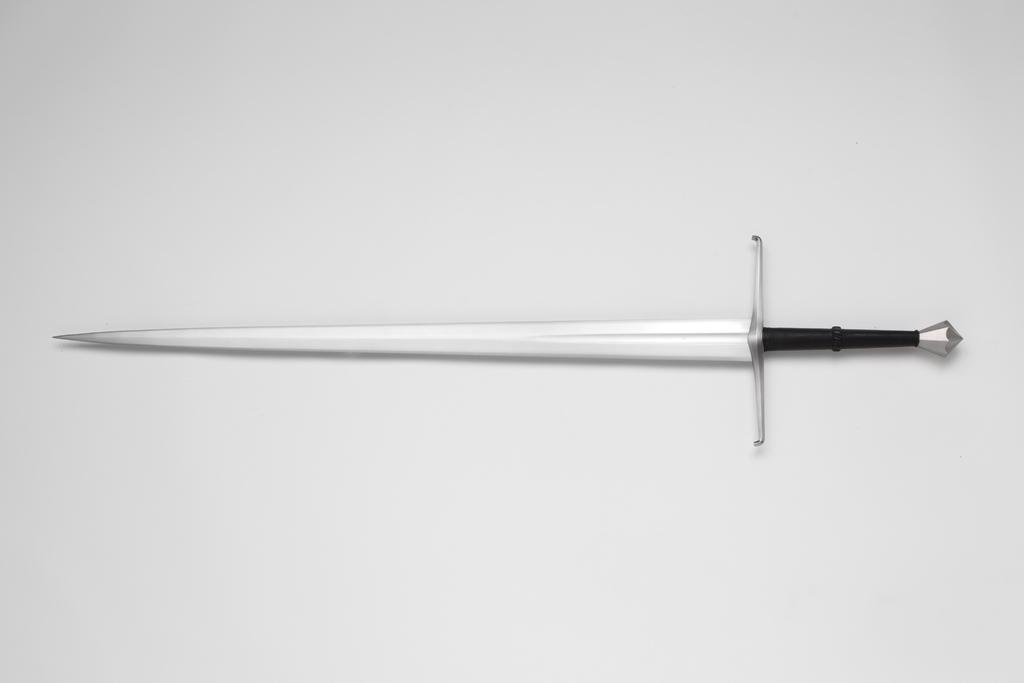What is the main object in the center of the image? There is a sword in the center of the image. How much money is being exchanged in the image? There is no money exchange depicted in the image; it only features a sword. What type of experience can be gained from the image? The image does not depict any experience or activity that can be gained; it only features a sword. 